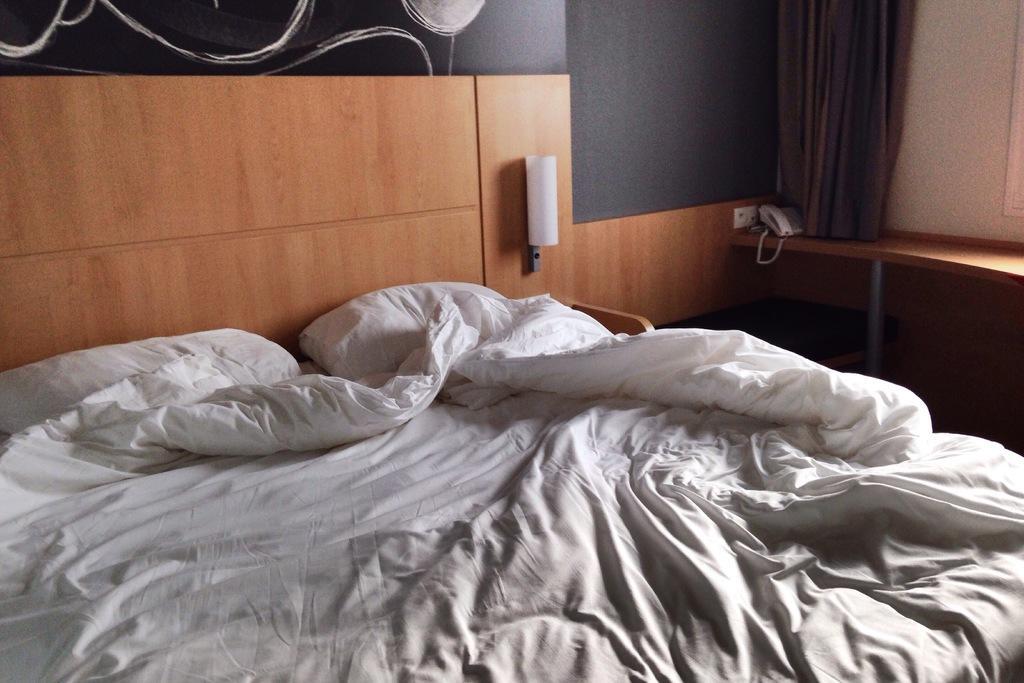In one or two sentences, can you explain what this image depicts? This picture is clicked inside a room. In the middle there is a bed, bed sheet, pillows. On the right there is a table, tel phone, curtain and wall. 